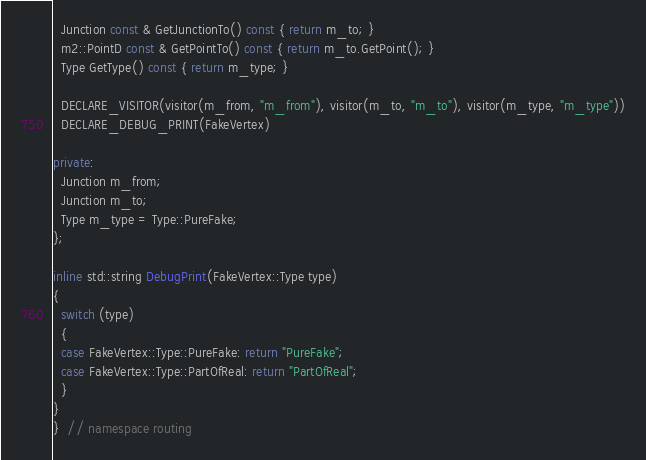<code> <loc_0><loc_0><loc_500><loc_500><_C++_>  Junction const & GetJunctionTo() const { return m_to; }
  m2::PointD const & GetPointTo() const { return m_to.GetPoint(); }
  Type GetType() const { return m_type; }

  DECLARE_VISITOR(visitor(m_from, "m_from"), visitor(m_to, "m_to"), visitor(m_type, "m_type"))
  DECLARE_DEBUG_PRINT(FakeVertex)

private:
  Junction m_from;
  Junction m_to;
  Type m_type = Type::PureFake;
};

inline std::string DebugPrint(FakeVertex::Type type)
{
  switch (type)
  {
  case FakeVertex::Type::PureFake: return "PureFake";
  case FakeVertex::Type::PartOfReal: return "PartOfReal";
  }
}
}  // namespace routing
</code> 